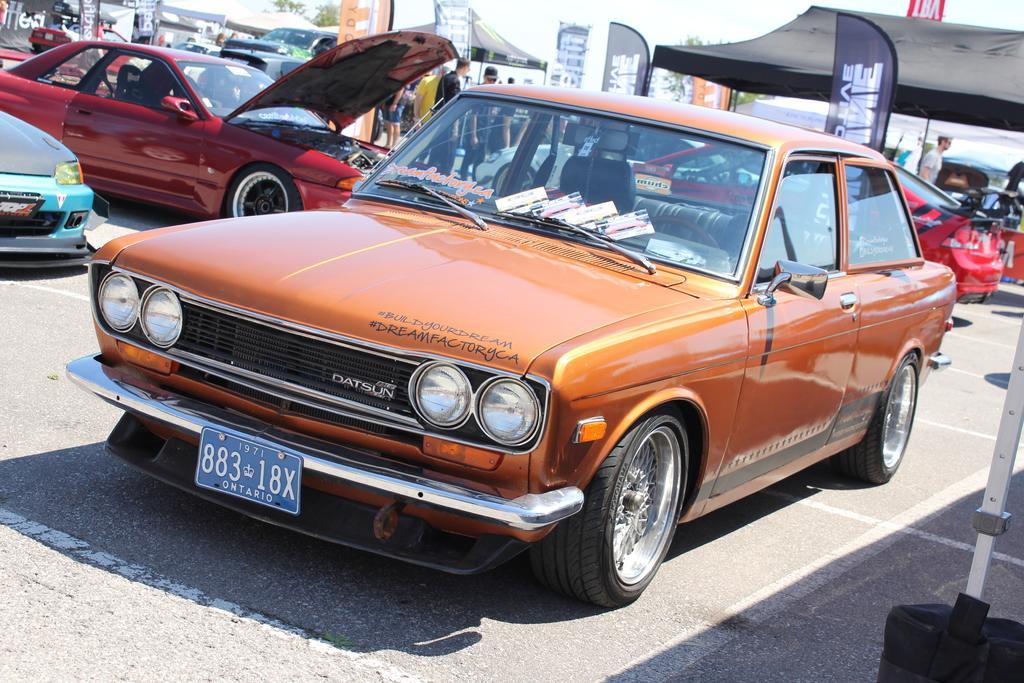Please provide a concise description of this image. In this image we can see some group of cars which are parked and are of different colors and models and in the background of the image there are some persons visiting there is tent and some banners. 